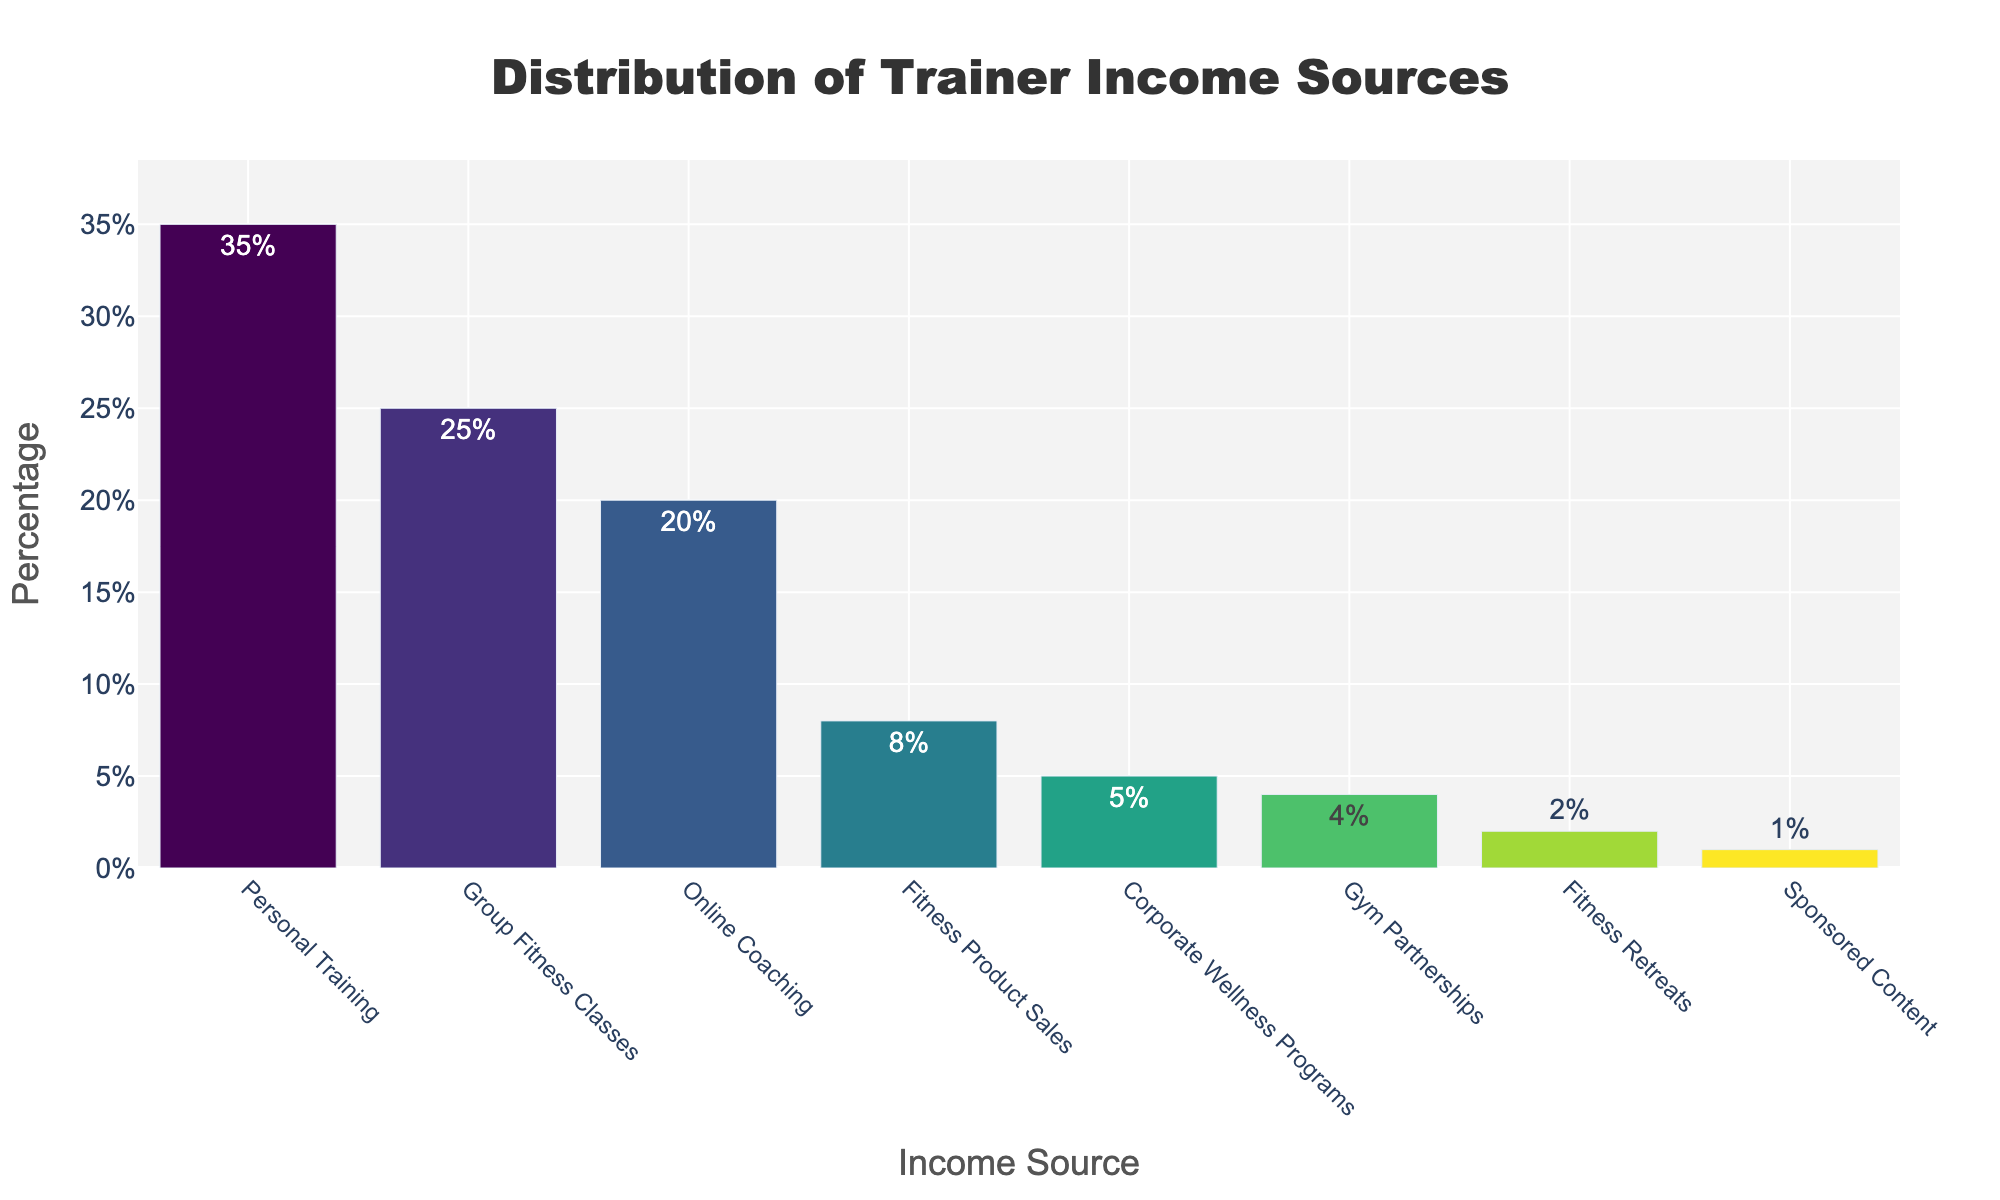What is the most significant income source for trainers? The figure shows the income sources sorted by percentage. The bar representing 'Personal Training' is the tallest, indicating it is the largest contributor.
Answer: Personal Training Which income source has the smallest contribution to the trainer's income? The shortest bar in the figure represents 'Sponsored Content,' indicating it has the smallest percentage.
Answer: Sponsored Content How much greater is the percentage of income from Personal Training compared to Online Coaching? The percentage for Personal Training is 35%, and for Online Coaching, it is 20%. The difference is 35% - 20%.
Answer: 15% What is the combined percentage of income from Group Fitness Classes and Corporate Wellness Programs? The percentage for Group Fitness Classes is 25%, and for Corporate Wellness Programs, it is 5%. The combined total is 25% + 5%.
Answer: 30% Which two income sources have a combined contribution that is equal to the contribution from Group Fitness Classes alone? Group Fitness Classes contribute 25%. Fitness Product Sales (8%) and Corporate Wellness Programs (5%) together contribute 8% + 5% = 13%. Other combinations do not match exactly. Therefore, no two sources equal 25%.
Answer: None Among the income sources, which one makes up less than a tenth (10%) of the total contributions? By inspection, Fitness Product Sales (8%), Corporate Wellness Programs (5%), Gym Partnerships (4%), Fitness Retreats (2%), and Sponsored Content (1%) each contribute less than 10%.
Answer: Fitness Product Sales, Corporate Wellness Programs, Gym Partnerships, Fitness Retreats, Sponsored Content What is the percentage difference between the highest and lowest income sources? The highest percentage is Personal Training at 35%, and the lowest is Sponsored Content at 1%. The difference is 35% - 1%.
Answer: 34% How does the percentage of income from Fitness Product Sales compare to Gym Partnerships and Fitness Retreats combined? Fitness Product Sales contribute 8%. Gym Partnerships and Fitness Retreats together contribute 4% + 2% = 6%. Therefore, Fitness Product Sales contribute a greater percentage.
Answer: Greater What visual characteristic distinguishes the highest income source in the chart? The highest income source, Personal Training, is represented by the tallest bar in the chart.
Answer: Tallest bar 